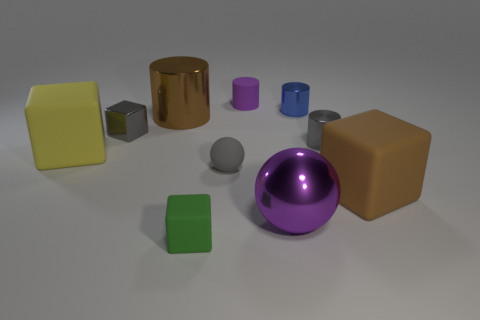Subtract all green cylinders. Subtract all gray blocks. How many cylinders are left? 4 Subtract all yellow cylinders. How many blue balls are left? 0 Add 2 grays. How many small greens exist? 0 Subtract all yellow blocks. Subtract all yellow objects. How many objects are left? 8 Add 3 big yellow blocks. How many big yellow blocks are left? 4 Add 10 big blue things. How many big blue things exist? 10 Subtract all green blocks. How many blocks are left? 3 Subtract all gray blocks. How many blocks are left? 3 Subtract 0 brown spheres. How many objects are left? 10 Subtract all spheres. How many objects are left? 8 